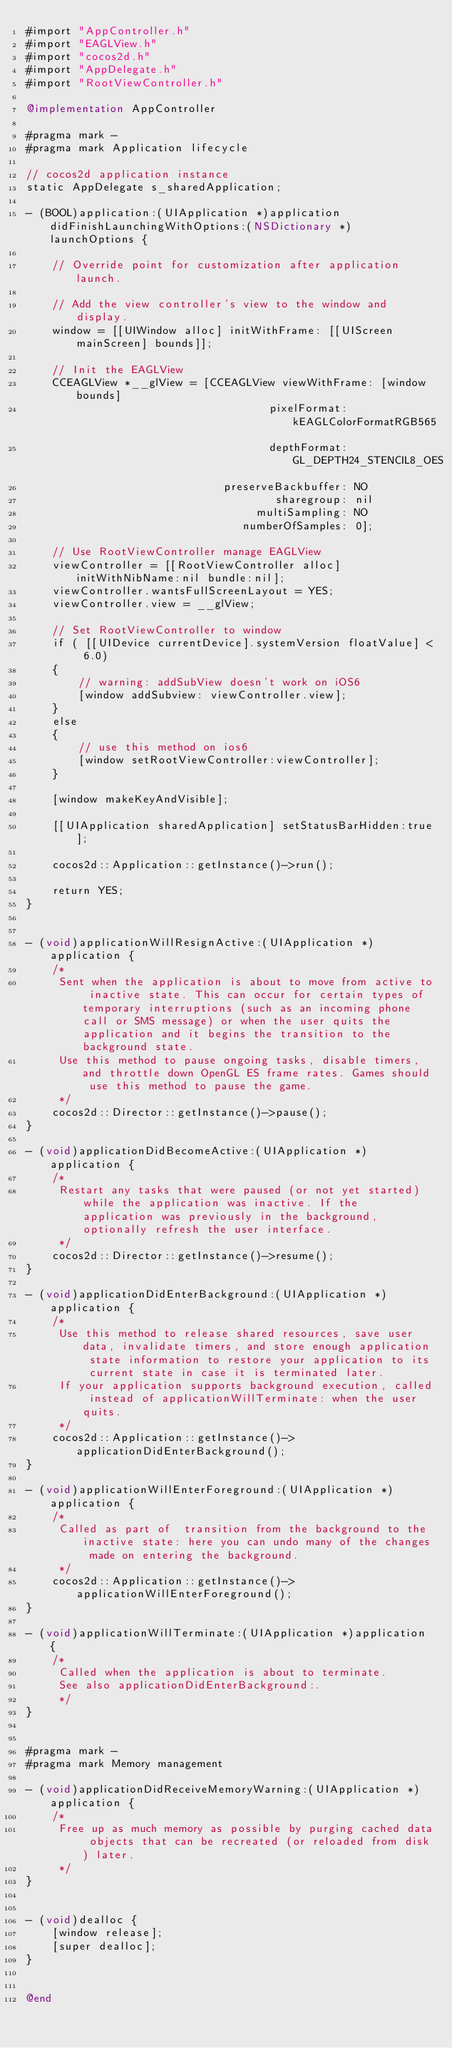Convert code to text. <code><loc_0><loc_0><loc_500><loc_500><_ObjectiveC_>#import "AppController.h"
#import "EAGLView.h"
#import "cocos2d.h"
#import "AppDelegate.h"
#import "RootViewController.h"

@implementation AppController

#pragma mark -
#pragma mark Application lifecycle

// cocos2d application instance
static AppDelegate s_sharedApplication;

- (BOOL)application:(UIApplication *)application didFinishLaunchingWithOptions:(NSDictionary *)launchOptions {    
    
    // Override point for customization after application launch.

    // Add the view controller's view to the window and display.
    window = [[UIWindow alloc] initWithFrame: [[UIScreen mainScreen] bounds]];
    
    // Init the EAGLView
    CCEAGLView *__glView = [CCEAGLView viewWithFrame: [window bounds]
                                     pixelFormat: kEAGLColorFormatRGB565
                                     depthFormat: GL_DEPTH24_STENCIL8_OES
                              preserveBackbuffer: NO
                                      sharegroup: nil
                                   multiSampling: NO
                                 numberOfSamples: 0];

    // Use RootViewController manage EAGLView 
    viewController = [[RootViewController alloc] initWithNibName:nil bundle:nil];
    viewController.wantsFullScreenLayout = YES;
    viewController.view = __glView;

    // Set RootViewController to window
    if ( [[UIDevice currentDevice].systemVersion floatValue] < 6.0)
    {
        // warning: addSubView doesn't work on iOS6
        [window addSubview: viewController.view];
    }
    else
    {
        // use this method on ios6
        [window setRootViewController:viewController];
    }
    
    [window makeKeyAndVisible];
    
    [[UIApplication sharedApplication] setStatusBarHidden:true];
    
    cocos2d::Application::getInstance()->run();

    return YES;
}


- (void)applicationWillResignActive:(UIApplication *)application {
    /*
     Sent when the application is about to move from active to inactive state. This can occur for certain types of temporary interruptions (such as an incoming phone call or SMS message) or when the user quits the application and it begins the transition to the background state.
     Use this method to pause ongoing tasks, disable timers, and throttle down OpenGL ES frame rates. Games should use this method to pause the game.
     */
    cocos2d::Director::getInstance()->pause();
}

- (void)applicationDidBecomeActive:(UIApplication *)application {
    /*
     Restart any tasks that were paused (or not yet started) while the application was inactive. If the application was previously in the background, optionally refresh the user interface.
     */
    cocos2d::Director::getInstance()->resume();
}

- (void)applicationDidEnterBackground:(UIApplication *)application {
    /*
     Use this method to release shared resources, save user data, invalidate timers, and store enough application state information to restore your application to its current state in case it is terminated later. 
     If your application supports background execution, called instead of applicationWillTerminate: when the user quits.
     */
    cocos2d::Application::getInstance()->applicationDidEnterBackground();
}

- (void)applicationWillEnterForeground:(UIApplication *)application {
    /*
     Called as part of  transition from the background to the inactive state: here you can undo many of the changes made on entering the background.
     */
    cocos2d::Application::getInstance()->applicationWillEnterForeground();
}

- (void)applicationWillTerminate:(UIApplication *)application {
    /*
     Called when the application is about to terminate.
     See also applicationDidEnterBackground:.
     */
}


#pragma mark -
#pragma mark Memory management

- (void)applicationDidReceiveMemoryWarning:(UIApplication *)application {
    /*
     Free up as much memory as possible by purging cached data objects that can be recreated (or reloaded from disk) later.
     */
}


- (void)dealloc {
    [window release];
    [super dealloc];
}


@end
</code> 